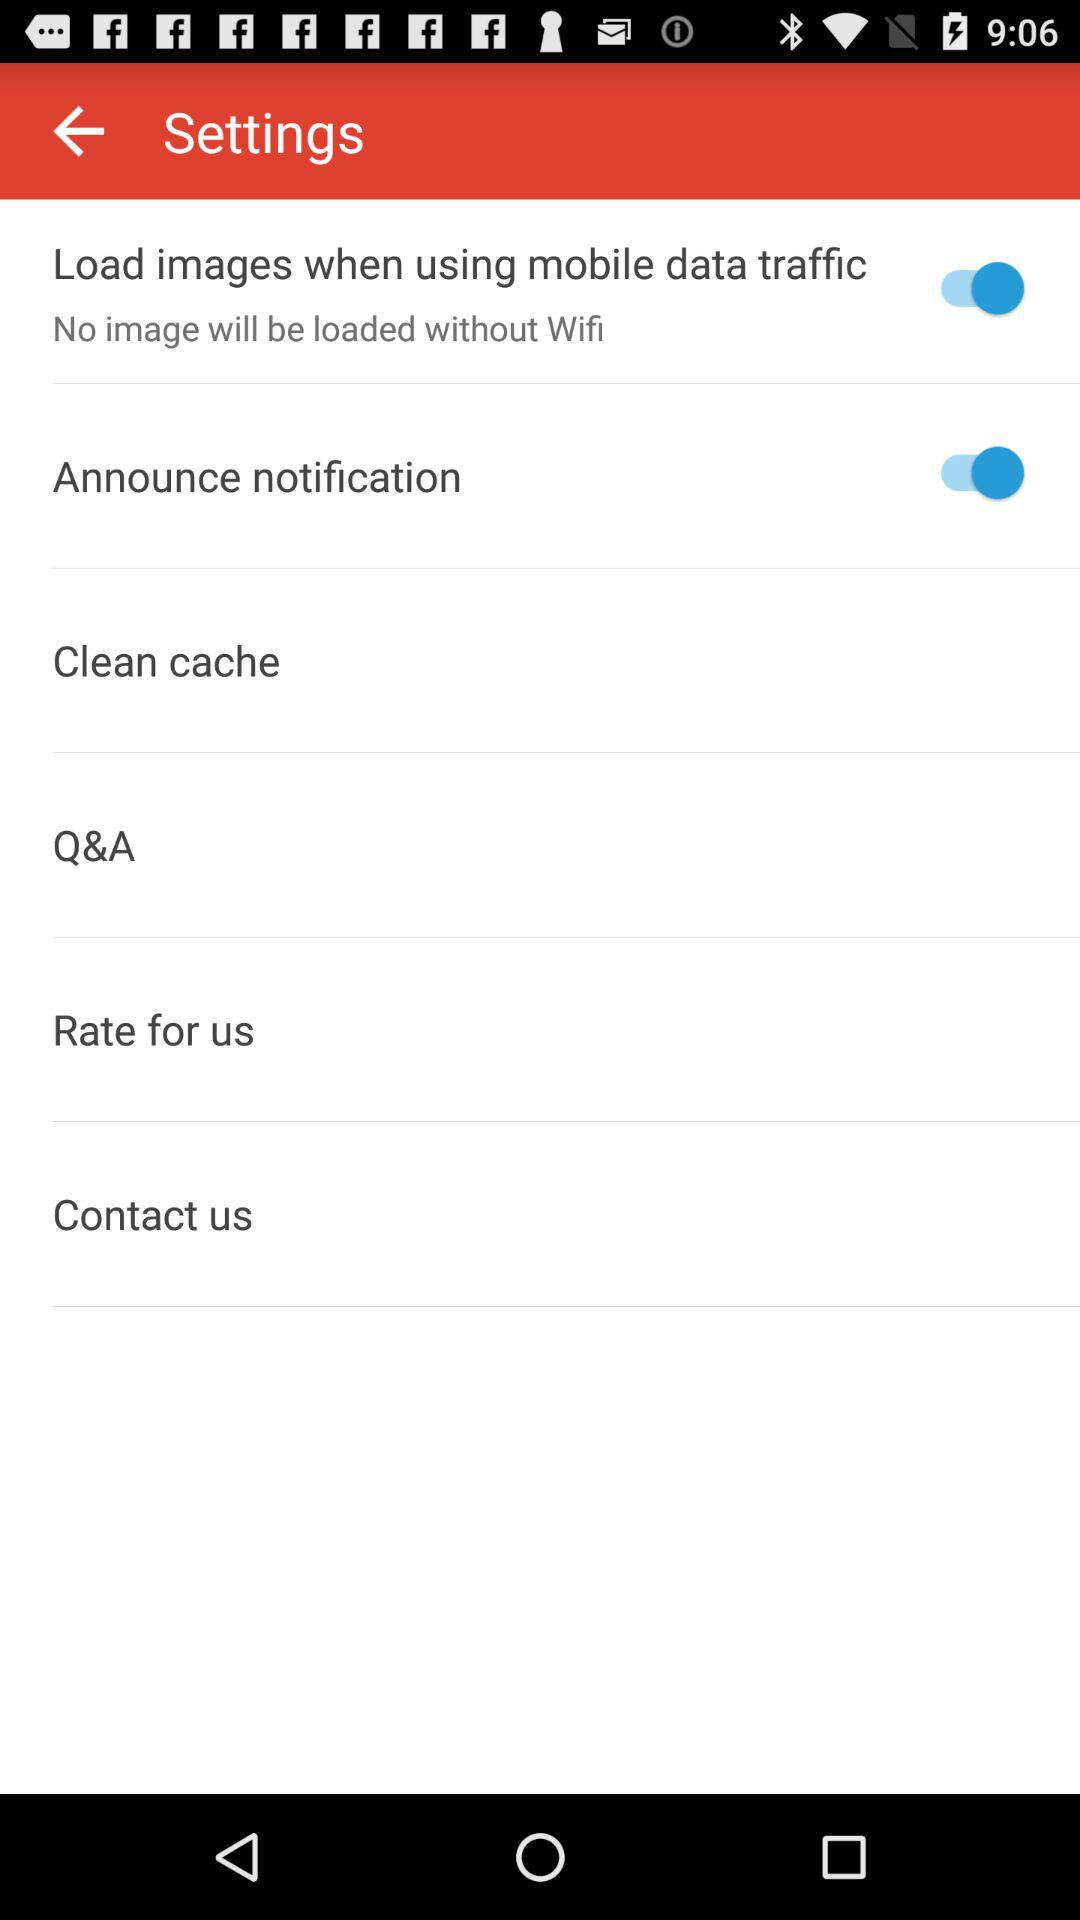How many settings are turned on?
Answer the question using a single word or phrase. 2 